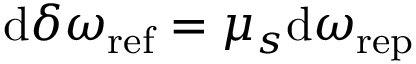<formula> <loc_0><loc_0><loc_500><loc_500>d \delta \omega _ { r e f } = \mu _ { s } d \omega _ { r e p }</formula> 